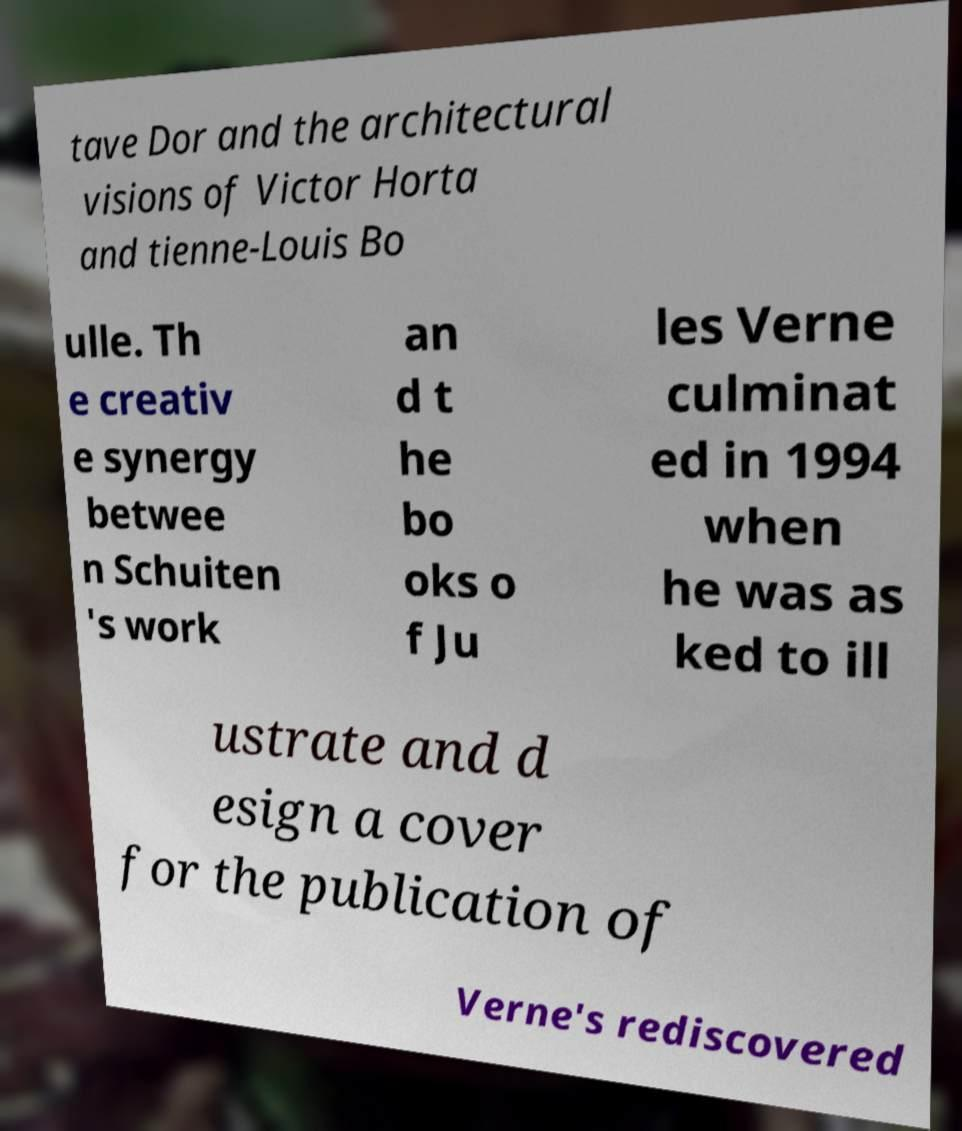Please read and relay the text visible in this image. What does it say? tave Dor and the architectural visions of Victor Horta and tienne-Louis Bo ulle. Th e creativ e synergy betwee n Schuiten 's work an d t he bo oks o f Ju les Verne culminat ed in 1994 when he was as ked to ill ustrate and d esign a cover for the publication of Verne's rediscovered 